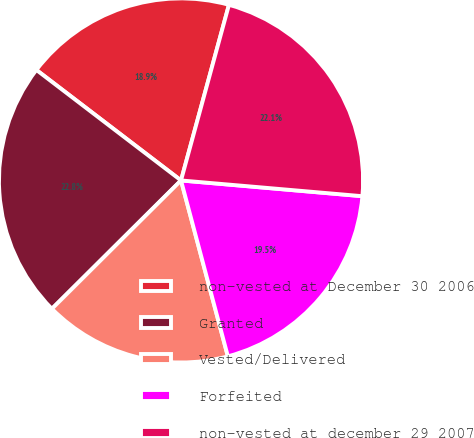Convert chart to OTSL. <chart><loc_0><loc_0><loc_500><loc_500><pie_chart><fcel>non-vested at December 30 2006<fcel>Granted<fcel>Vested/Delivered<fcel>Forfeited<fcel>non-vested at december 29 2007<nl><fcel>18.86%<fcel>22.84%<fcel>16.69%<fcel>19.48%<fcel>22.14%<nl></chart> 